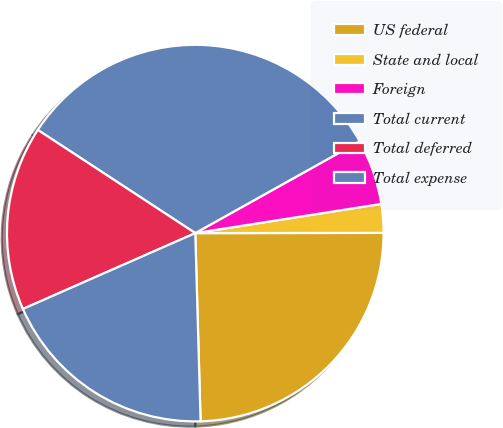Convert chart. <chart><loc_0><loc_0><loc_500><loc_500><pie_chart><fcel>US federal<fcel>State and local<fcel>Foreign<fcel>Total current<fcel>Total deferred<fcel>Total expense<nl><fcel>24.57%<fcel>2.46%<fcel>5.63%<fcel>32.66%<fcel>15.83%<fcel>18.85%<nl></chart> 